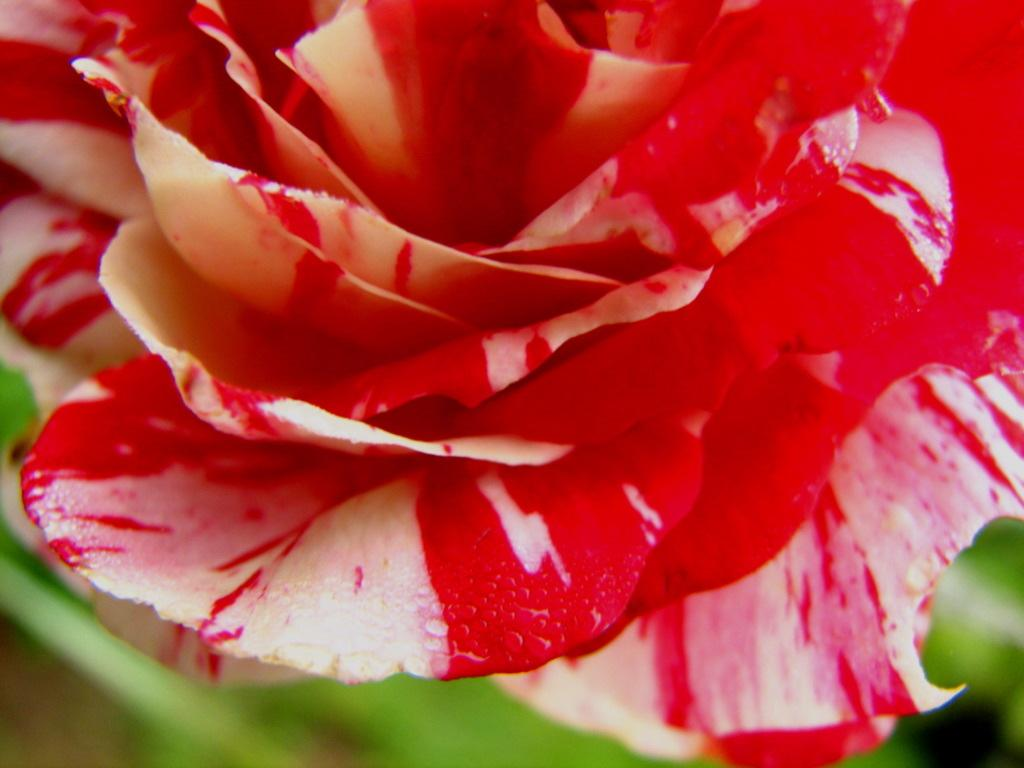What is the main subject of the image? The main subject of the image is a flower. Can you describe the flower in the image? Unfortunately, the provided facts do not include any details about the flower's appearance or characteristics. Is the flower the only subject in the image? Based on the given facts, it appears that the flower is the only subject in the image. How many chess pieces can be seen on the table next to the flower in the image? There is no table or chess pieces present in the image; it is a zoom-in picture of a flower. 